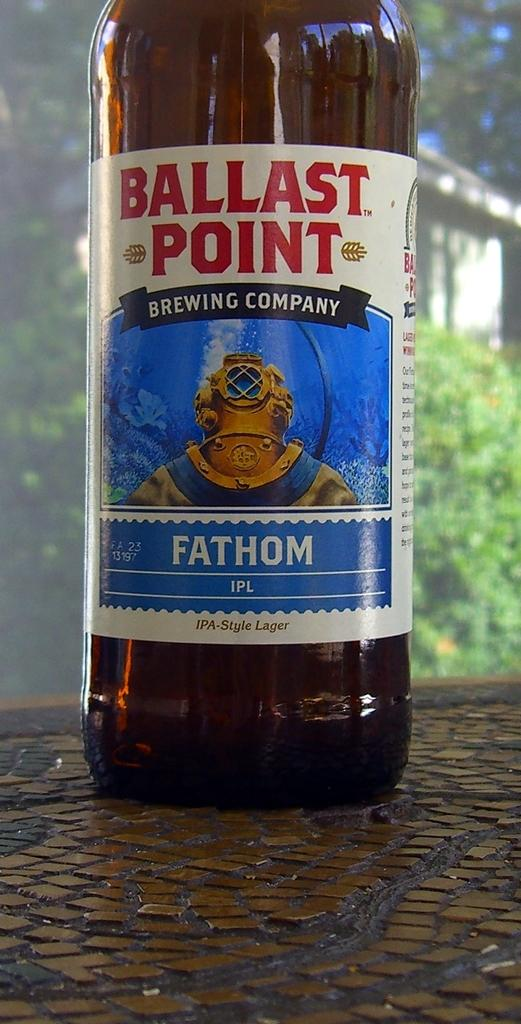What is located in the middle of the image? There is a bottle in the middle of the image. What can be found on the bottle? There is text on the bottle. What can be seen in the background of the image? There are trees in the background of the image. Can you tell me how many celery stalks are visible in the image? There is no celery present in the image. What is the limit of the park shown in the image? There is no park present in the image. 